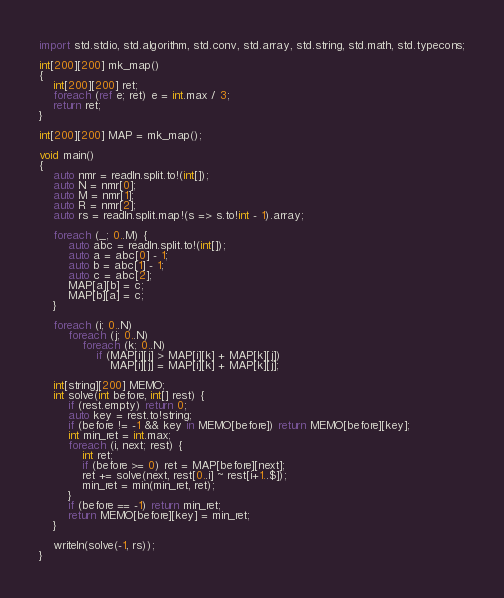<code> <loc_0><loc_0><loc_500><loc_500><_D_>import std.stdio, std.algorithm, std.conv, std.array, std.string, std.math, std.typecons;

int[200][200] mk_map()
{
    int[200][200] ret;
    foreach (ref e; ret) e = int.max / 3;
    return ret;
}

int[200][200] MAP = mk_map();

void main()
{
    auto nmr = readln.split.to!(int[]);
    auto N = nmr[0];
    auto M = nmr[1];
    auto R = nmr[2];
    auto rs = readln.split.map!(s => s.to!int - 1).array;

    foreach (_; 0..M) {
        auto abc = readln.split.to!(int[]);
        auto a = abc[0] - 1;
        auto b = abc[1] - 1;
        auto c = abc[2];
        MAP[a][b] = c;
        MAP[b][a] = c;
    }

    foreach (i; 0..N)
        foreach (j; 0..N)
            foreach (k; 0..N)
                if (MAP[i][j] > MAP[i][k] + MAP[k][j])
                    MAP[i][j] = MAP[i][k] + MAP[k][j];

    int[string][200] MEMO;
    int solve(int before, int[] rest) {
        if (rest.empty) return 0;
        auto key = rest.to!string;
        if (before != -1 && key in MEMO[before]) return MEMO[before][key];
        int min_ret = int.max;
        foreach (i, next; rest) {
            int ret;
            if (before >= 0) ret = MAP[before][next];
            ret += solve(next, rest[0..i] ~ rest[i+1..$]);
            min_ret = min(min_ret, ret);
        }
        if (before == -1) return min_ret;
        return MEMO[before][key] = min_ret;
    }

    writeln(solve(-1, rs));
}</code> 